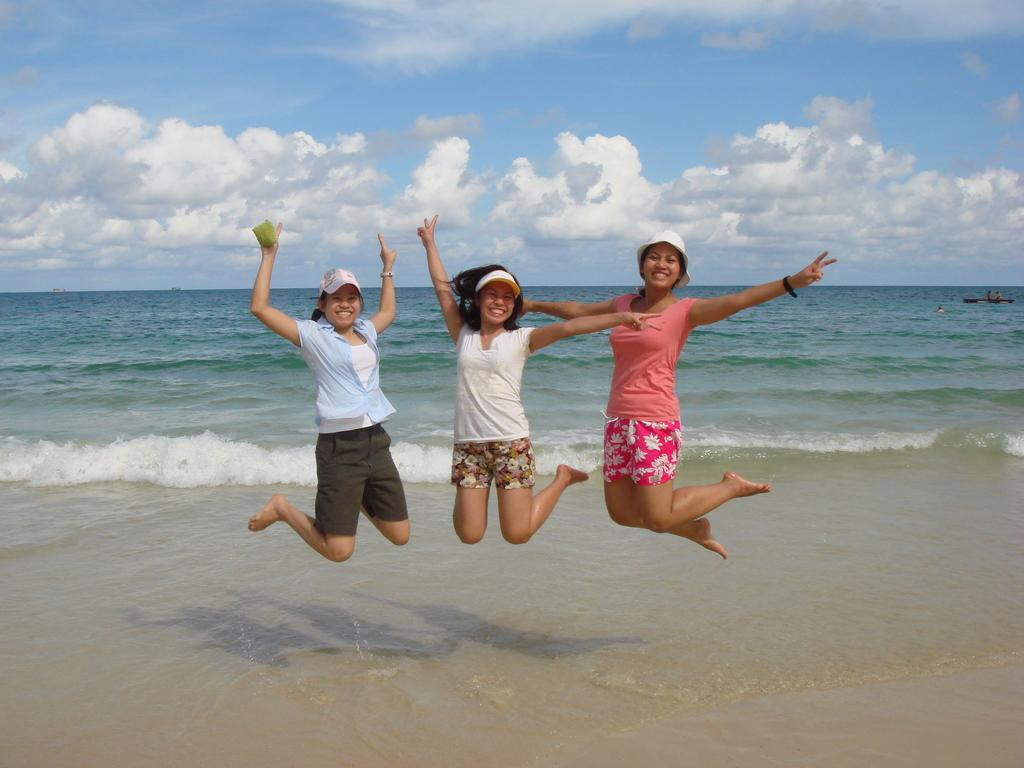How many people are in the image? There are three persons in the image. What are the persons doing in the image? The persons are jumping and smiling. What type of environment is visible in the image? There is water and sand at the bottom of the image, and the sky is visible with clouds. What type of rice can be seen growing in the image? There is no rice visible in the image; it features three people jumping and smiling in a water and sand environment. Can you see any ants crawling on the persons in the image? There are no ants visible in the image; the focus is on the people and their actions. 